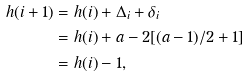Convert formula to latex. <formula><loc_0><loc_0><loc_500><loc_500>h ( i + 1 ) & = h ( i ) + \Delta _ { i } + \delta _ { i } \\ & = h ( i ) + a - 2 [ ( a - 1 ) / 2 + 1 ] \\ & = h ( i ) - 1 ,</formula> 